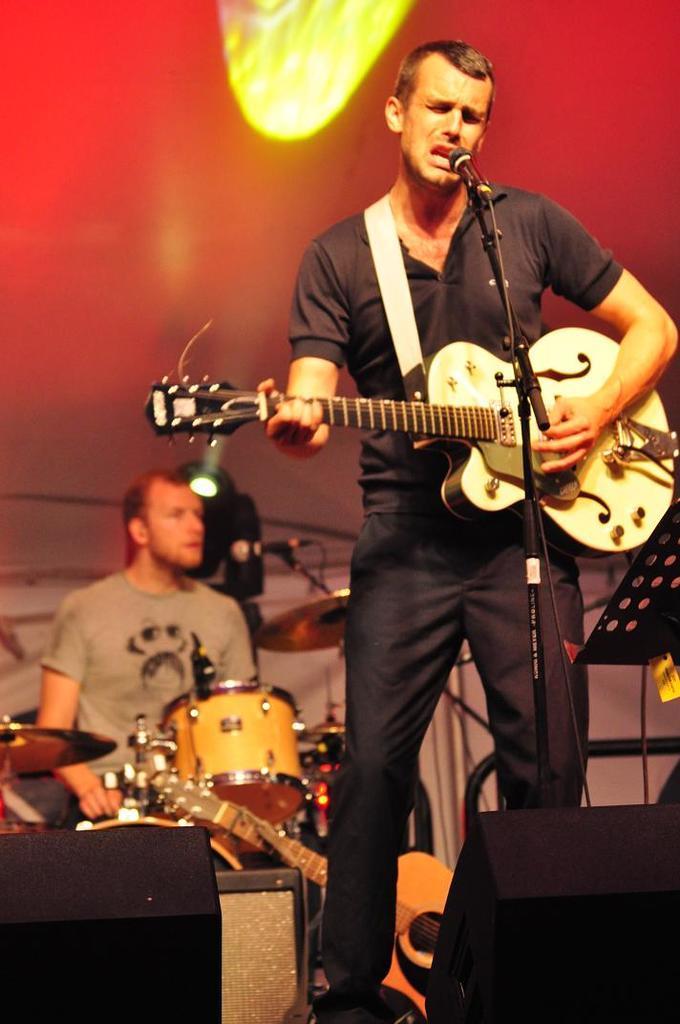In one or two sentences, can you explain what this image depicts? This man is playing guitar and singing in-front of mic. Far this person is playing this musical instruments. On top there is a focusing lights. 